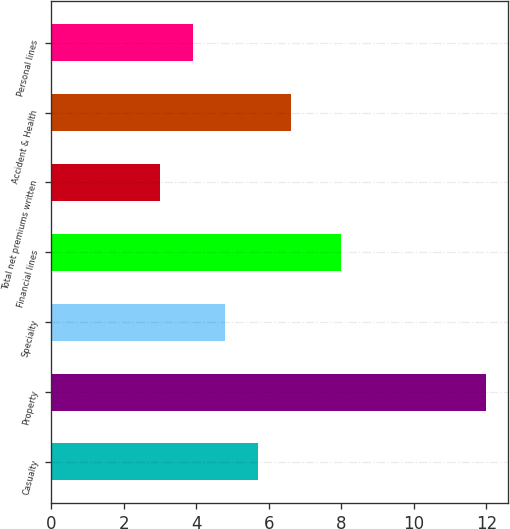Convert chart to OTSL. <chart><loc_0><loc_0><loc_500><loc_500><bar_chart><fcel>Casualty<fcel>Property<fcel>Specialty<fcel>Financial lines<fcel>Total net premiums written<fcel>Accident & Health<fcel>Personal lines<nl><fcel>5.7<fcel>12<fcel>4.8<fcel>8<fcel>3<fcel>6.6<fcel>3.9<nl></chart> 